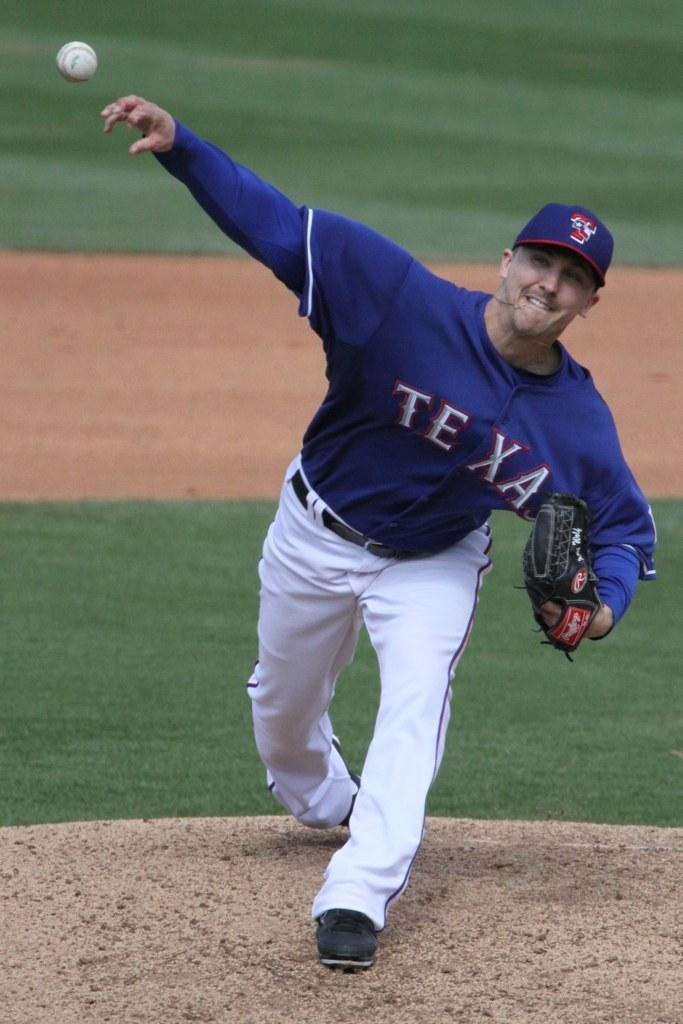<image>
Offer a succinct explanation of the picture presented. A  man in a blue Texas jersey pitching a baseball. 